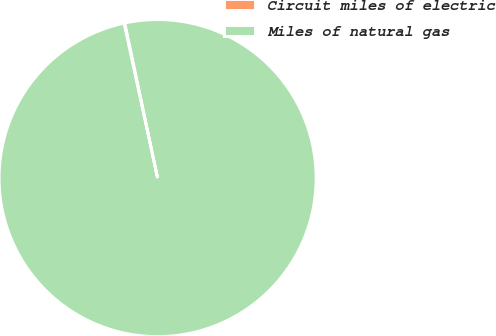Convert chart. <chart><loc_0><loc_0><loc_500><loc_500><pie_chart><fcel>Circuit miles of electric<fcel>Miles of natural gas<nl><fcel>0.08%<fcel>99.92%<nl></chart> 